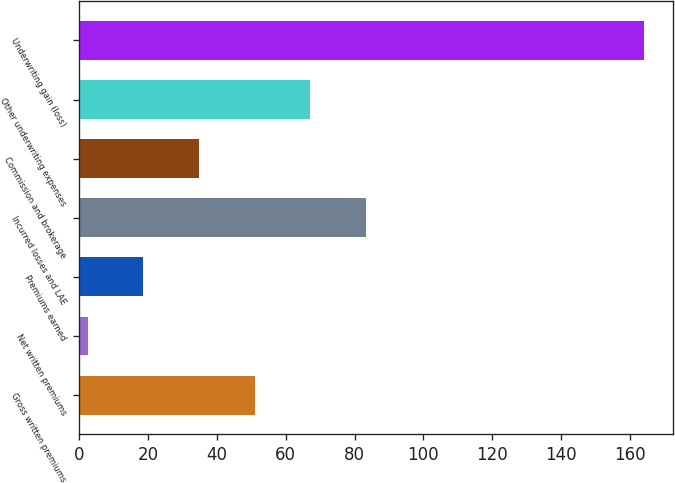Convert chart. <chart><loc_0><loc_0><loc_500><loc_500><bar_chart><fcel>Gross written premiums<fcel>Net written premiums<fcel>Premiums earned<fcel>Incurred losses and LAE<fcel>Commission and brokerage<fcel>Other underwriting expenses<fcel>Underwriting gain (loss)<nl><fcel>50.94<fcel>2.4<fcel>18.58<fcel>83.3<fcel>34.76<fcel>67.12<fcel>164.2<nl></chart> 